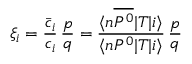Convert formula to latex. <formula><loc_0><loc_0><loc_500><loc_500>\xi _ { i } = \frac { \bar { c } _ { i } } { c _ { i } } \, \frac { p } { q } = \frac { \langle n \overline { { { P ^ { 0 } } } } | T | i \rangle } { \langle n P ^ { 0 } | T | i \rangle } \, \frac { p } { q }</formula> 